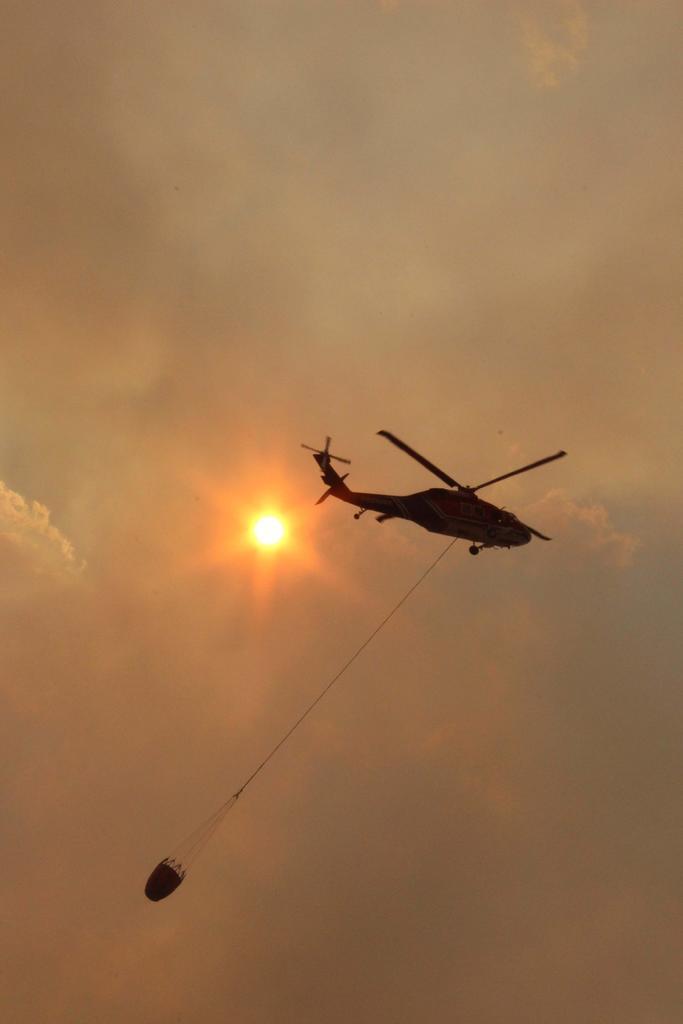Describe this image in one or two sentences. This image consists of a helicopter flying in the air. And there is something tied to it. In the background, there is a sun and clouds in the sky. 